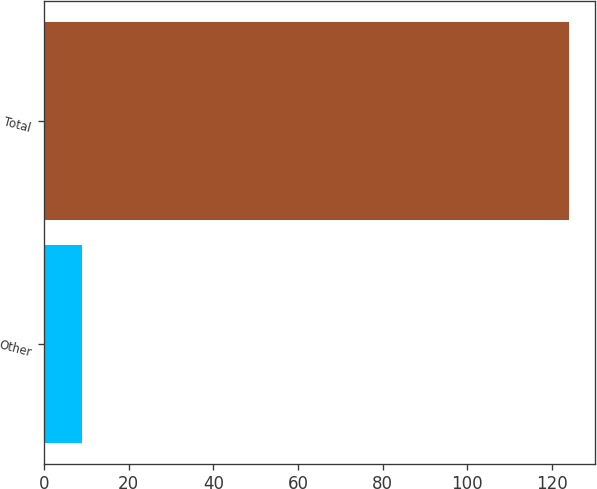<chart> <loc_0><loc_0><loc_500><loc_500><bar_chart><fcel>Other<fcel>Total<nl><fcel>9<fcel>124<nl></chart> 